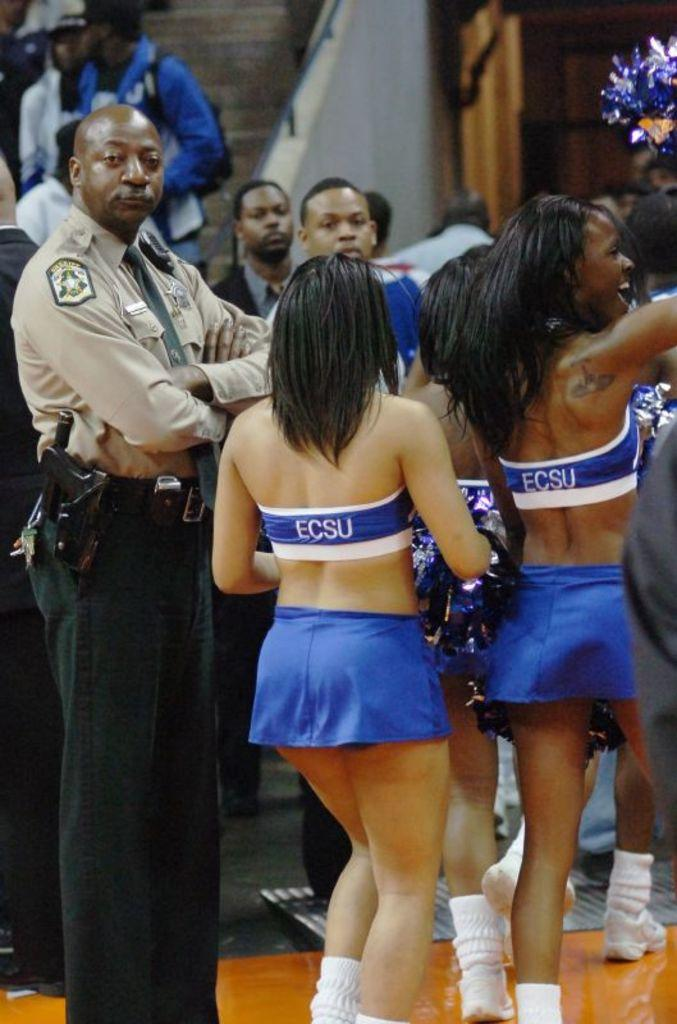<image>
Share a concise interpretation of the image provided. ECSU is the name shown on the back of these cheerleader's uniforms. 